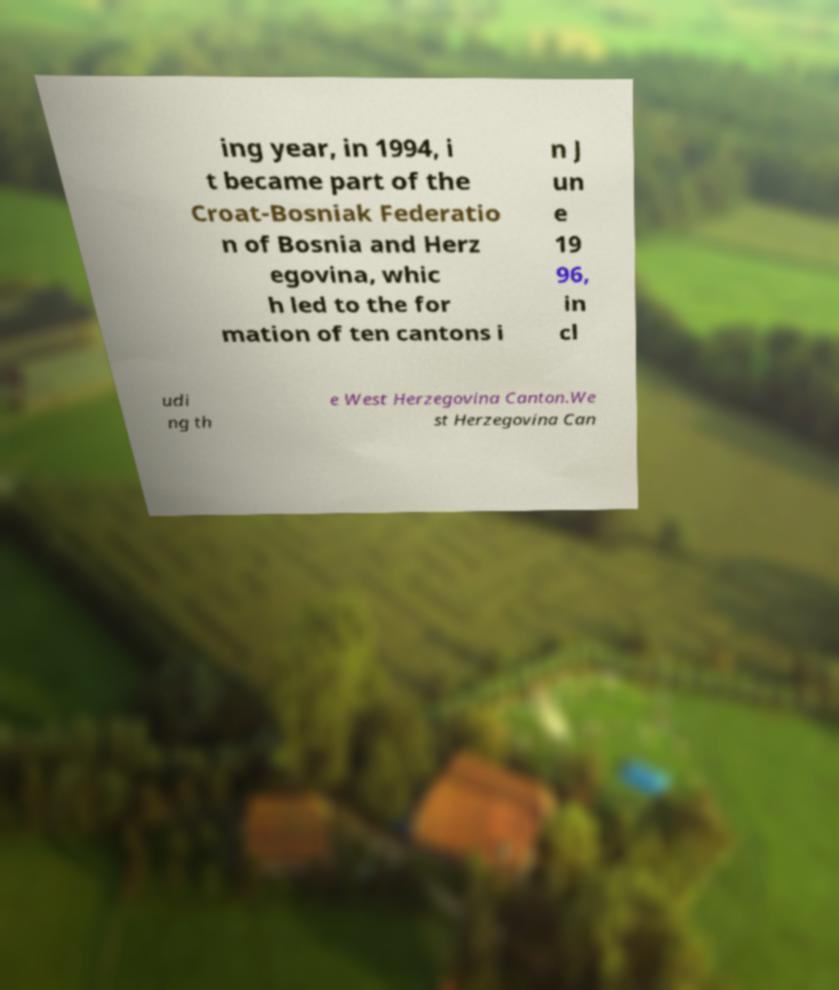What messages or text are displayed in this image? I need them in a readable, typed format. ing year, in 1994, i t became part of the Croat-Bosniak Federatio n of Bosnia and Herz egovina, whic h led to the for mation of ten cantons i n J un e 19 96, in cl udi ng th e West Herzegovina Canton.We st Herzegovina Can 